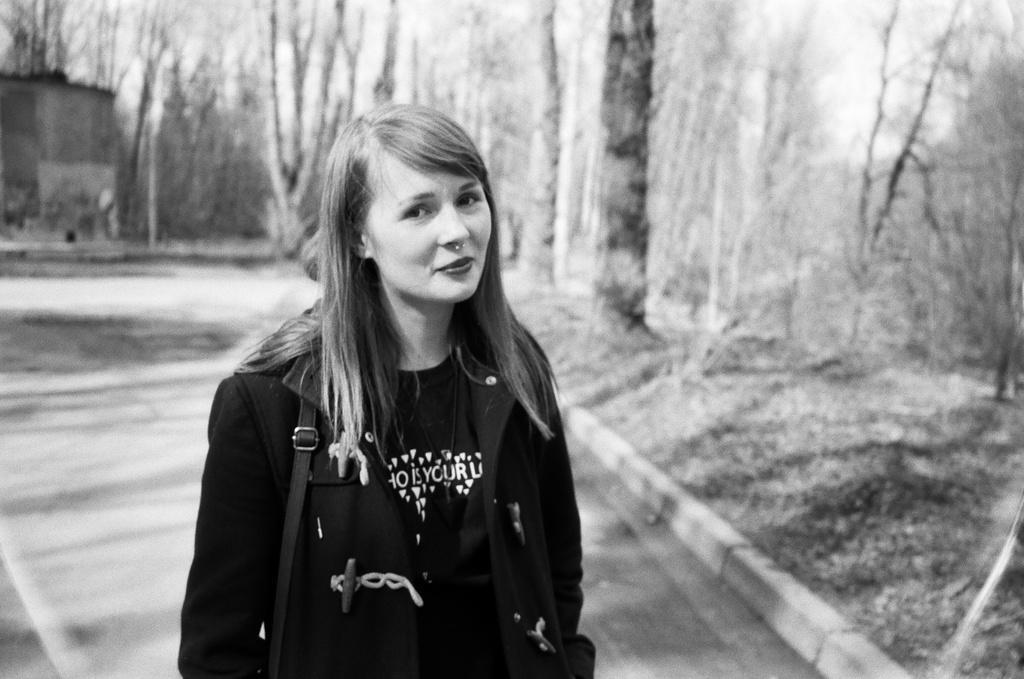Describe this image in one or two sentences. It is the black and white image in which there is a girl standing on the floor. The girl is wearing the black colour jacket and a handbag. On the right side there are trees on the footpath. On the left side top there is a small house in the background. 